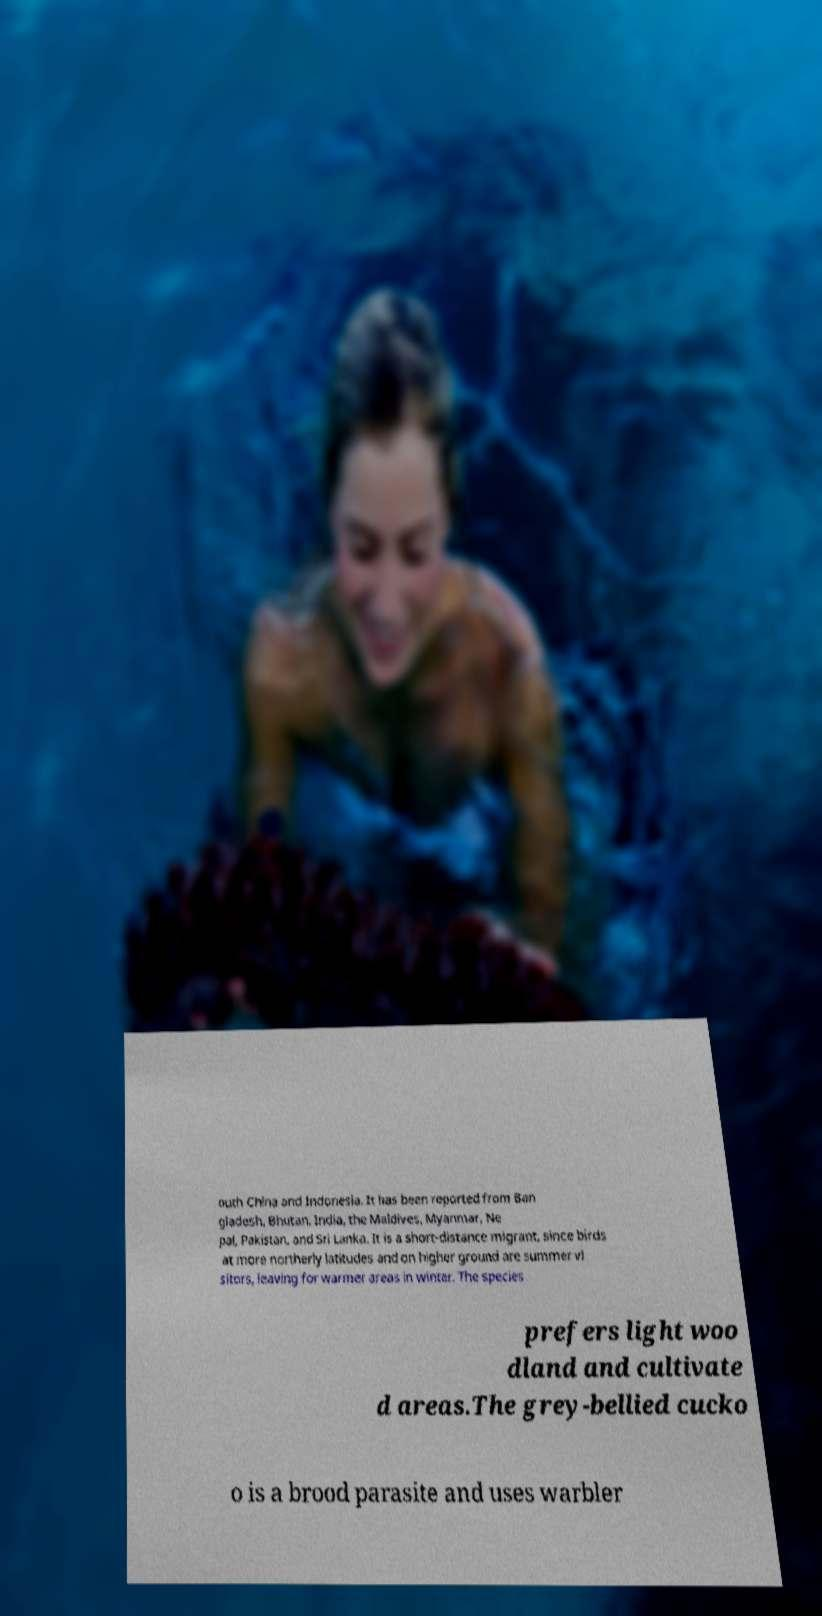What messages or text are displayed in this image? I need them in a readable, typed format. outh China and Indonesia. It has been reported from Ban gladesh, Bhutan, India, the Maldives, Myanmar, Ne pal, Pakistan, and Sri Lanka. It is a short-distance migrant, since birds at more northerly latitudes and on higher ground are summer vi sitors, leaving for warmer areas in winter. The species prefers light woo dland and cultivate d areas.The grey-bellied cucko o is a brood parasite and uses warbler 